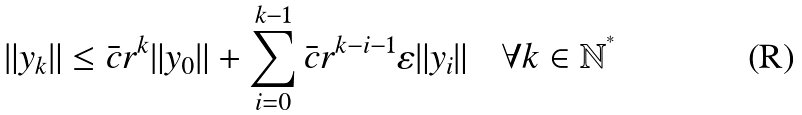<formula> <loc_0><loc_0><loc_500><loc_500>\| y _ { k } \| \leq \bar { c } r ^ { k } \| y _ { 0 } \| + \sum _ { i = 0 } ^ { k - 1 } \bar { c } r ^ { k - i - 1 } \varepsilon \| y _ { i } \| \quad \forall k \in \mathbb { N ^ { ^ { * } } }</formula> 